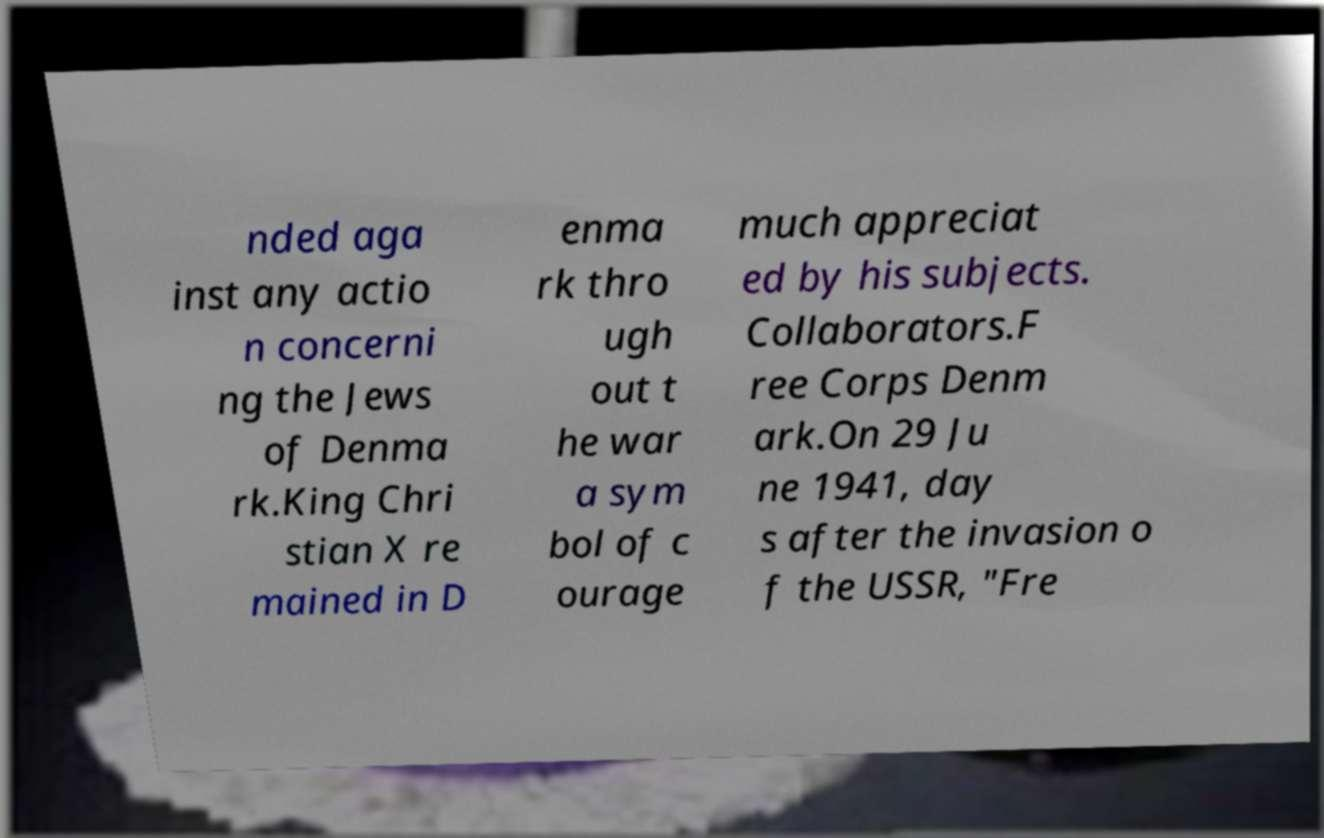Please read and relay the text visible in this image. What does it say? nded aga inst any actio n concerni ng the Jews of Denma rk.King Chri stian X re mained in D enma rk thro ugh out t he war a sym bol of c ourage much appreciat ed by his subjects. Collaborators.F ree Corps Denm ark.On 29 Ju ne 1941, day s after the invasion o f the USSR, "Fre 